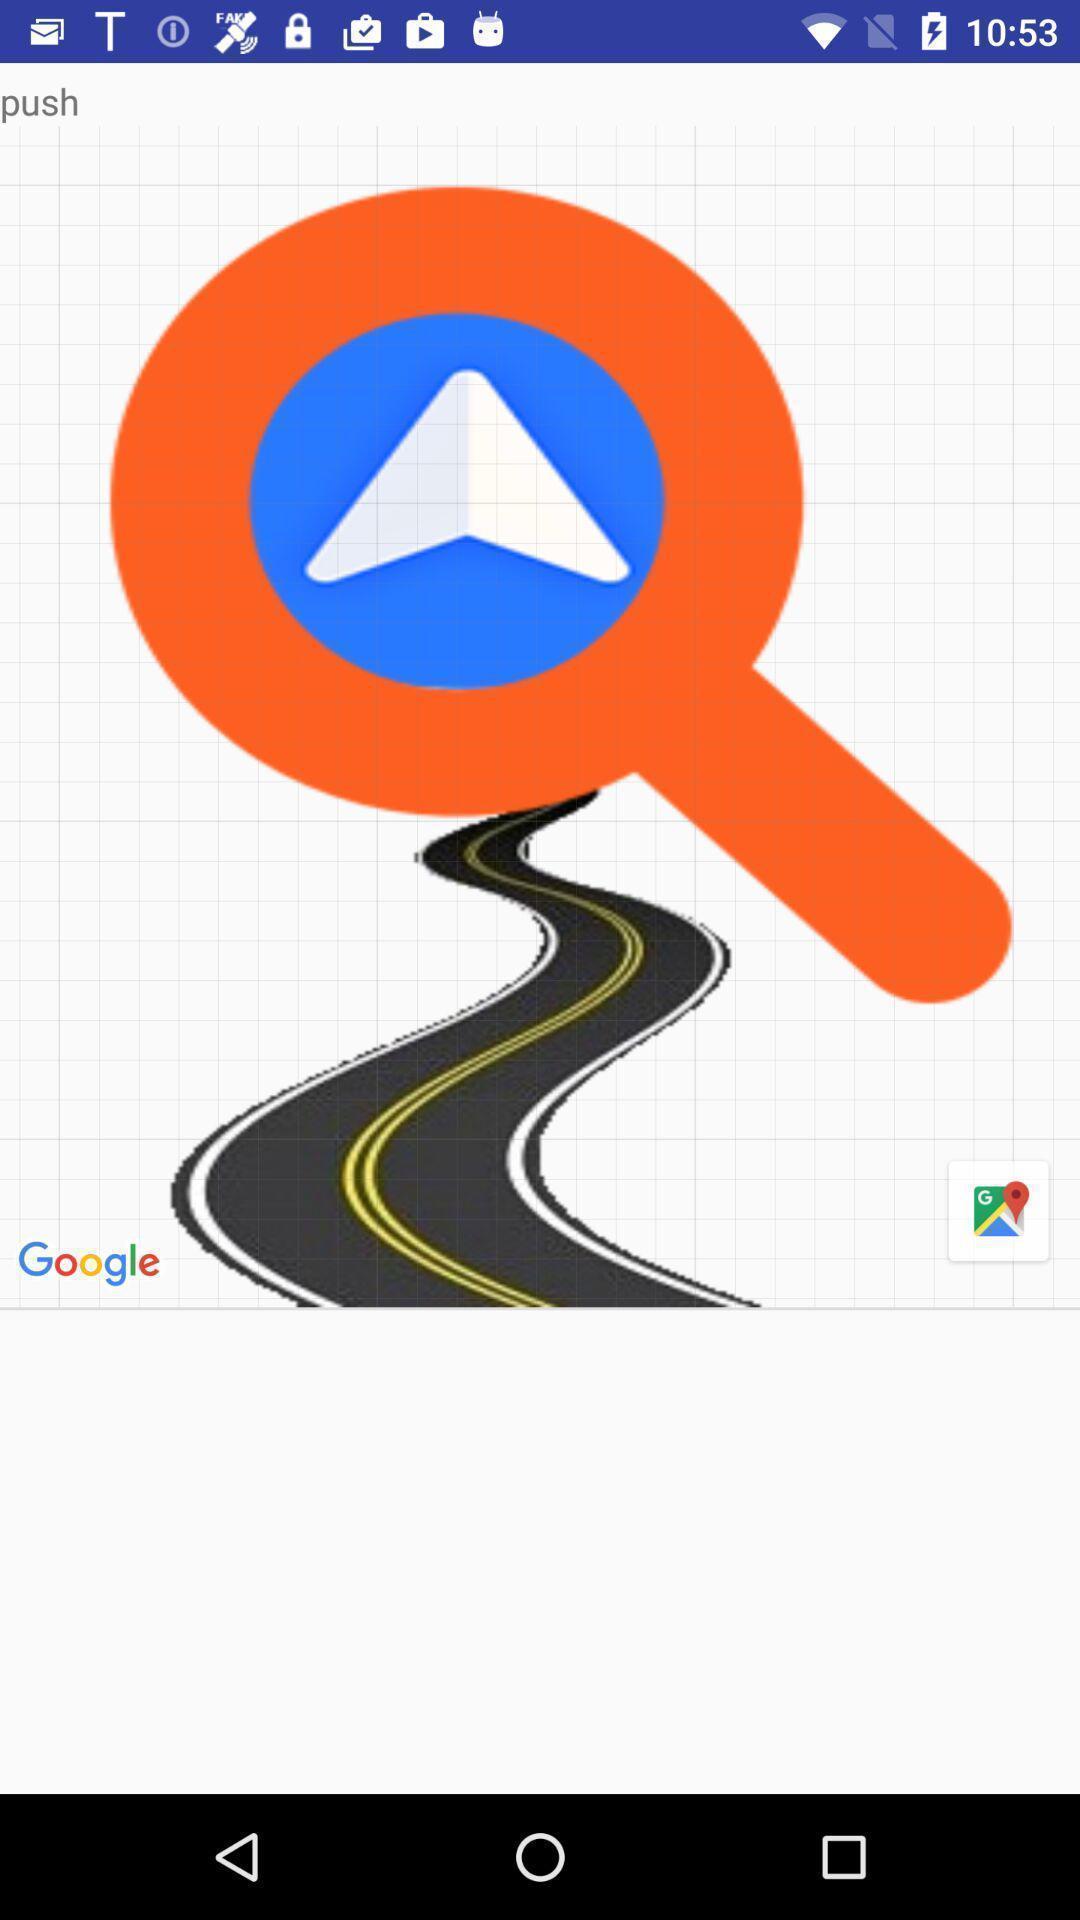Please provide a description for this image. Screen page displaying search icon in location app. 